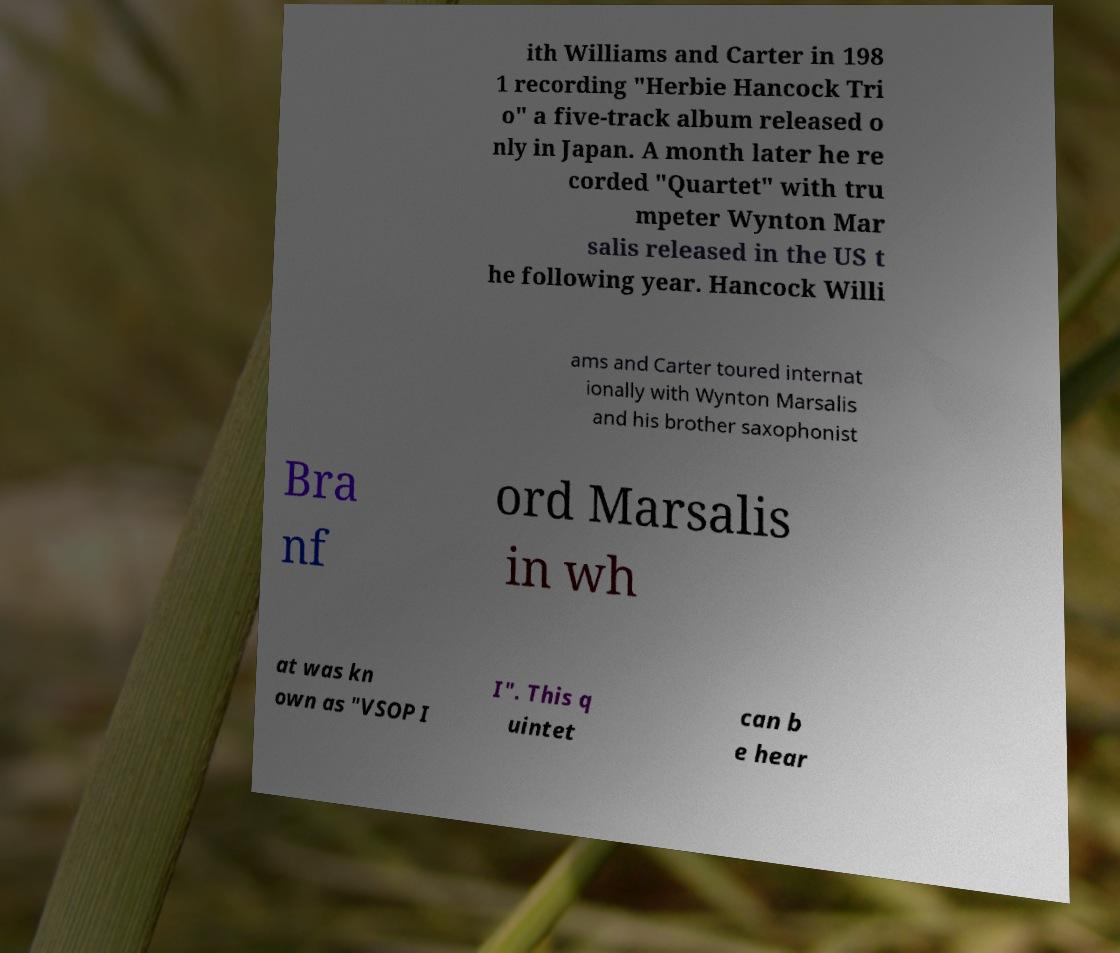Can you read and provide the text displayed in the image?This photo seems to have some interesting text. Can you extract and type it out for me? ith Williams and Carter in 198 1 recording "Herbie Hancock Tri o" a five-track album released o nly in Japan. A month later he re corded "Quartet" with tru mpeter Wynton Mar salis released in the US t he following year. Hancock Willi ams and Carter toured internat ionally with Wynton Marsalis and his brother saxophonist Bra nf ord Marsalis in wh at was kn own as "VSOP I I". This q uintet can b e hear 